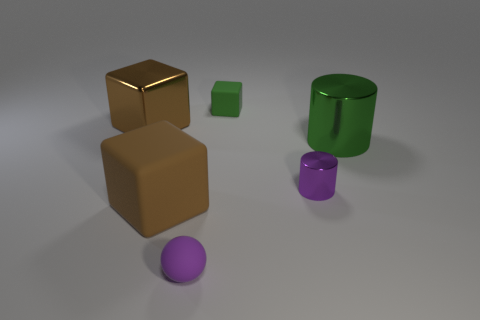How many brown cubes must be subtracted to get 1 brown cubes? 1 Add 3 big shiny cylinders. How many objects exist? 9 Subtract all spheres. How many objects are left? 5 Add 1 big green shiny things. How many big green shiny things exist? 2 Subtract 0 red cylinders. How many objects are left? 6 Subtract all purple blocks. Subtract all purple matte objects. How many objects are left? 5 Add 4 green rubber things. How many green rubber things are left? 5 